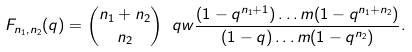Convert formula to latex. <formula><loc_0><loc_0><loc_500><loc_500>F _ { n _ { 1 } , n _ { 2 } } ( q ) = \binom { n _ { 1 } + n _ { 2 } } { n _ { 2 } } \ q w \frac { ( 1 - q ^ { n _ { 1 } + 1 } ) \dots m ( 1 - q ^ { n _ { 1 } + n _ { 2 } } ) } { ( 1 - q ) \dots m ( 1 - q ^ { n _ { 2 } } ) } .</formula> 